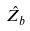<formula> <loc_0><loc_0><loc_500><loc_500>\hat { Z _ { b } }</formula> 